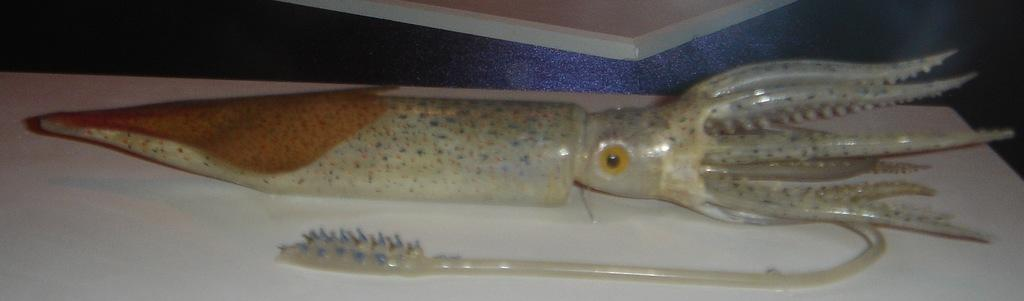What type of animal is in the image? There is an octopus in the image. Can you see any cows jumping in the river in the image? There is no river, cows, or jumping depicted in the image; it features an octopus. 